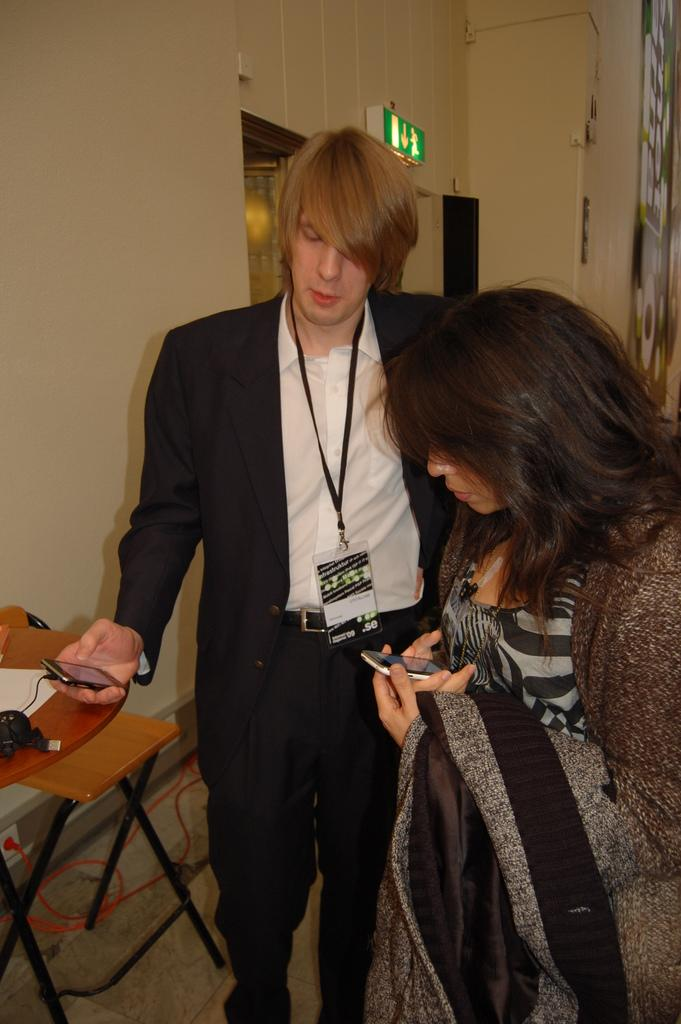How many people are present in the image? There are 2 people standing in the image. What is the person on the left wearing? The person on the left is wearing a black suit. What is the person on the left holding? The person on the left is holding a phone in his hand. What can be seen behind the people in the image? There is a wall visible behind the people. What type of bushes can be seen growing near the wall in the image? There are no bushes visible in the image; only a wall is present behind the people. 